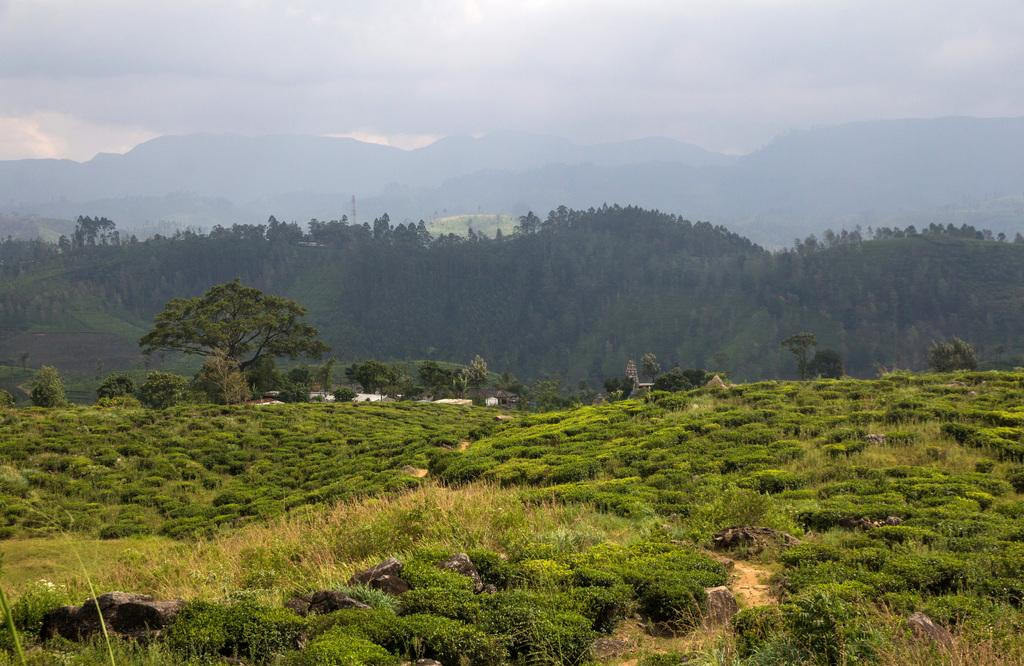What type of vegetation can be seen in the image? There is a group of trees in the image. What geographical feature is visible in the image? There are mountains visible in the image. What part of the natural environment is visible in the image? The sky is visible in the background of the image. What type of bubble can be seen floating near the trees in the image? There is no bubble present in the image; it features a group of trees, mountains, and the sky. 